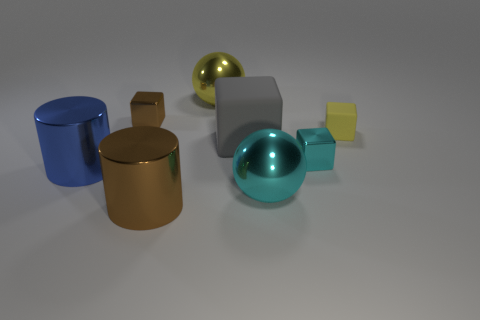There is a tiny thing that is behind the tiny yellow thing; what color is it?
Your answer should be very brief. Brown. What size is the other rubber thing that is the same shape as the small rubber thing?
Provide a succinct answer. Large. How many objects are either shiny things that are in front of the tiny yellow block or things that are in front of the small yellow rubber block?
Ensure brevity in your answer.  5. There is a shiny thing that is in front of the small cyan metal cube and behind the large cyan ball; how big is it?
Ensure brevity in your answer.  Large. Does the big gray rubber object have the same shape as the cyan metal object behind the big cyan shiny thing?
Your answer should be very brief. Yes. What number of things are either yellow objects on the right side of the gray rubber cube or yellow rubber cubes?
Offer a very short reply. 1. Does the yellow block have the same material as the big gray block to the left of the large cyan metallic sphere?
Your answer should be compact. Yes. The brown metal object in front of the cyan thing right of the big cyan object is what shape?
Give a very brief answer. Cylinder. There is a small matte block; is it the same color as the big metallic object behind the tiny yellow matte thing?
Your answer should be compact. Yes. The big gray rubber object is what shape?
Offer a terse response. Cube. 